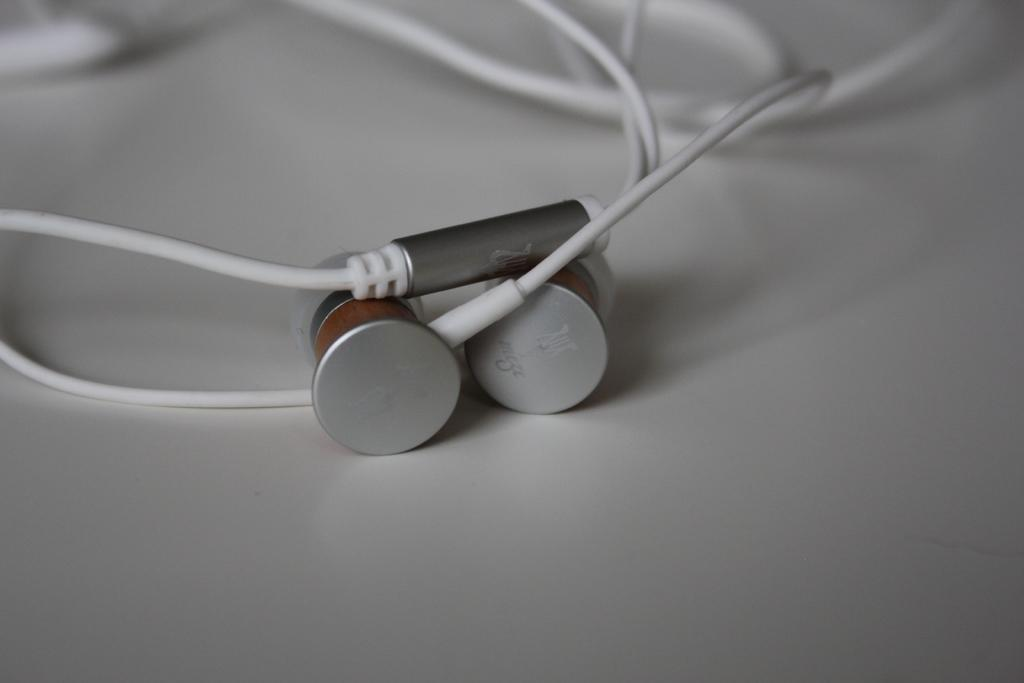What type of audio accessory is present in the image? There are earphones in the image. What color are the earphones? The earphones are white in color. Where are the earphones located in the image? The earphones are on a surface. What type of vegetable is growing in the image? There is no vegetable present in the image; it features earphones on a surface. How does the image promote peace? The image does not specifically promote peace, as it only shows earphones on a surface. 